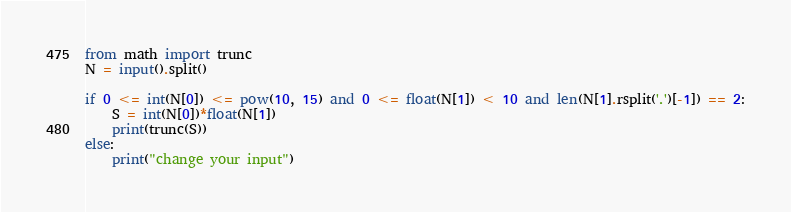Convert code to text. <code><loc_0><loc_0><loc_500><loc_500><_Python_>from math import trunc
N = input().split()

if 0 <= int(N[0]) <= pow(10, 15) and 0 <= float(N[1]) < 10 and len(N[1].rsplit('.')[-1]) == 2:
    S = int(N[0])*float(N[1])
    print(trunc(S))
else:
    print("change your input")</code> 